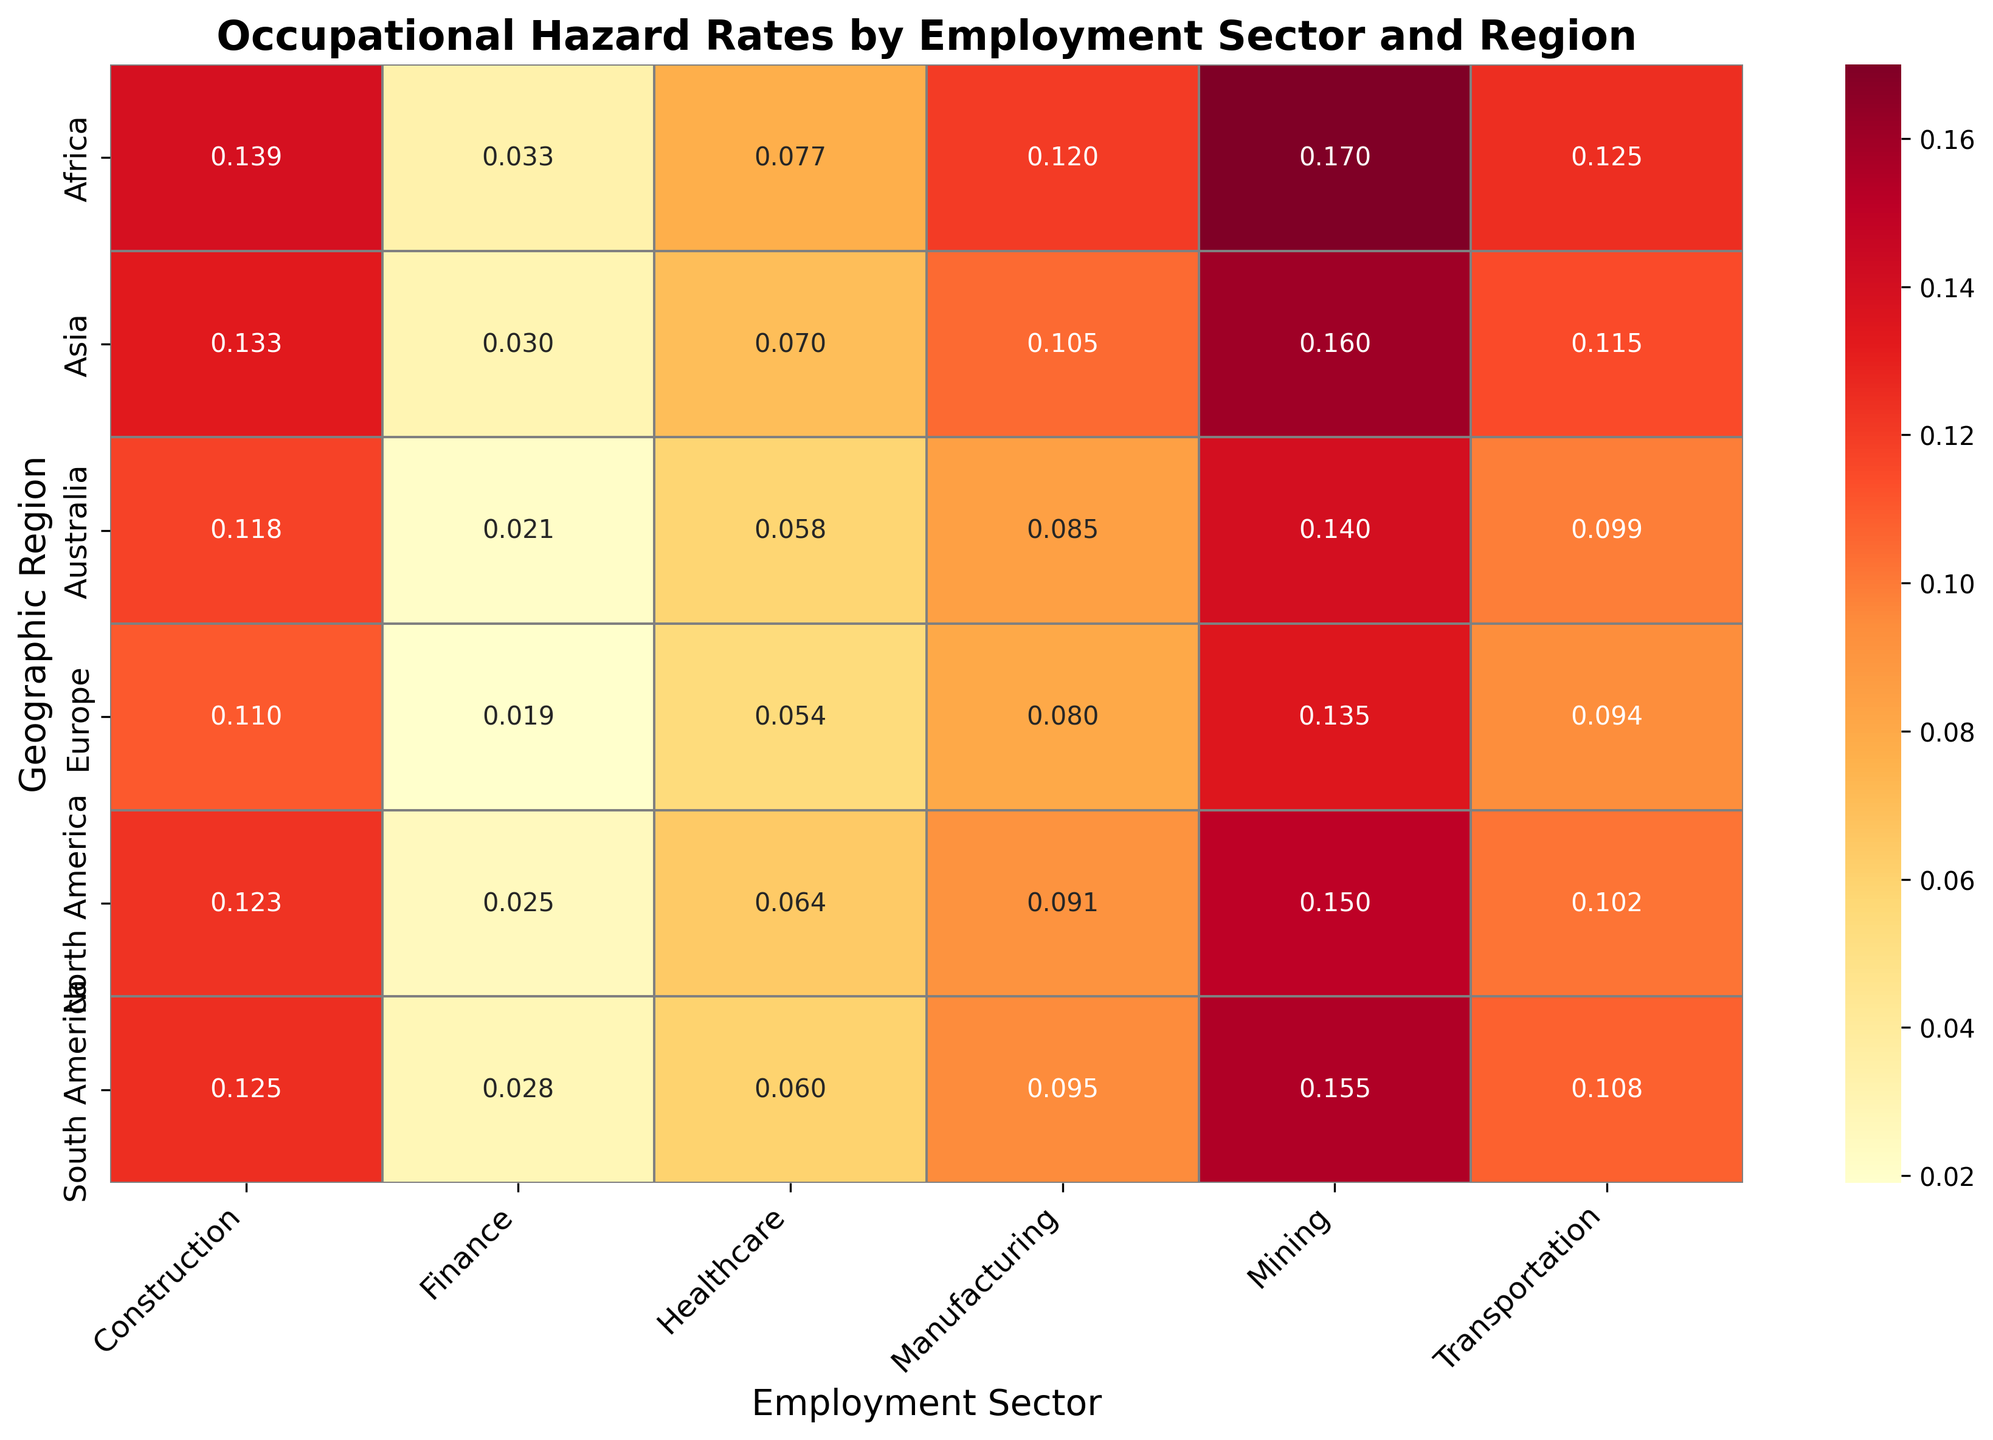Which employment sector in North America has the highest occupational hazard rate? According to the heatmap, Mining in North America has the highest occupational hazard rate. It's indicated by the darkest shade of red which signifies the highest values in the color gradient.
Answer: Mining How does the occupational hazard rate in Finance compare between North America and Europe? By examining the heatmap, the occupational hazard rate for Finance in North America and Europe are both indicated. North America has a rate of 0.025 while Europe has a slightly lower rate of 0.019. Comparing these, North America's rate is higher than Europe's.
Answer: North America is higher Which region has the most significant difference in occupational hazard rates between Manufacturing and Finance? The difference is calculated by subtracting the rate for Finance from that for Manufacturing in each region. Africa has the largest difference: 0.120 - 0.033 = 0.087. This is evident by visually comparing the range of color differences between these segments across regions.
Answer: Africa What is the average occupational hazard rate across all regions for the Healthcare sector? The rates for Healthcare in all regions are: 0.064 (North America), 0.054 (Europe), 0.070 (Asia), 0.060 (South America), 0.077 (Africa), 0.058 (Australia). Summing these values gives 0.383. Dividing by the number of regions (6), we get an average of 0.383 / 6 = 0.0638.
Answer: 0.064 In the Construction sector, which region has the lowest occupational hazard rate? Observing the heatmap, for the Construction sector, the rate values and corresponding colors are noted. North America has the lowest occupational hazard rate of 0.123 for Construction among the regions.
Answer: North America Is the occupational hazard rate higher in Manufacturing or Transportation in Asia? From the heatmap, we see that the occupational hazard rate for Manufacturing in Asia is 0.105 and for Transportation, it is 0.115. The color shade corresponding to Transportation is slightly darker, indicating a higher rate.
Answer: Transportation How does Africa's occupational hazard rate for Mining compare to the global average for Mining? Calculating the global average for mining: (0.150 + 0.135 + 0.160 + 0.155 + 0.170 + 0.140) / 6 = 0.152. Africa's rate for Mining is 0.170. Comparing, Africa's rate is higher than the global average.
Answer: Africa is higher Which sector in Europe has rates closely matching the average global occupational hazard rate for Healthcare? To determine the average global occupational hazard rate for Healthcare: (0.064 + 0.054 + 0.070 + 0.060 + 0.077 + 0.058) / 6 = 0.0638. The heatmap shows that Europe's Healthcare rate is 0.054, which is slightly below but close to the global average.
Answer: Healthcare 